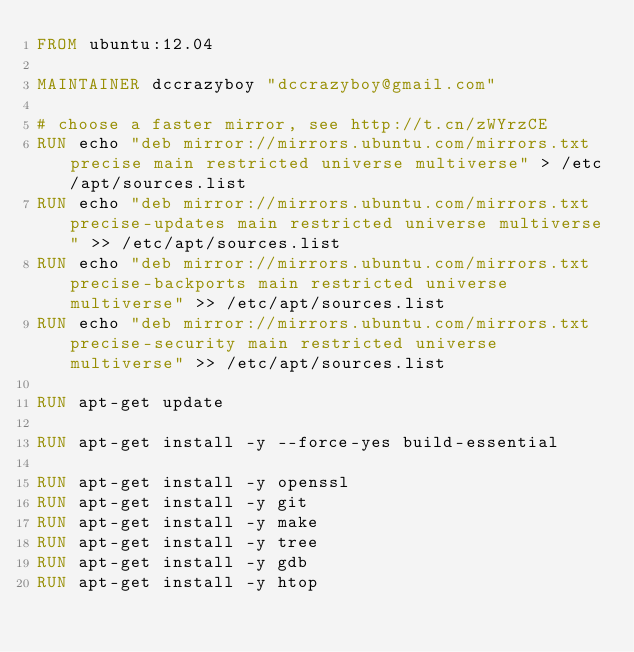<code> <loc_0><loc_0><loc_500><loc_500><_Dockerfile_>FROM ubuntu:12.04

MAINTAINER dccrazyboy "dccrazyboy@gmail.com"

# choose a faster mirror, see http://t.cn/zWYrzCE
RUN echo "deb mirror://mirrors.ubuntu.com/mirrors.txt precise main restricted universe multiverse" > /etc/apt/sources.list
RUN echo "deb mirror://mirrors.ubuntu.com/mirrors.txt precise-updates main restricted universe multiverse" >> /etc/apt/sources.list
RUN echo "deb mirror://mirrors.ubuntu.com/mirrors.txt precise-backports main restricted universe multiverse" >> /etc/apt/sources.list
RUN echo "deb mirror://mirrors.ubuntu.com/mirrors.txt precise-security main restricted universe multiverse" >> /etc/apt/sources.list

RUN apt-get update

RUN apt-get install -y --force-yes build-essential

RUN apt-get install -y openssl
RUN apt-get install -y git
RUN apt-get install -y make
RUN apt-get install -y tree
RUN apt-get install -y gdb
RUN apt-get install -y htop
</code> 